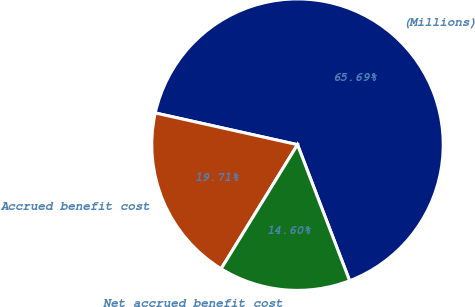<chart> <loc_0><loc_0><loc_500><loc_500><pie_chart><fcel>(Millions)<fcel>Accrued benefit cost<fcel>Net accrued benefit cost<nl><fcel>65.69%<fcel>19.71%<fcel>14.6%<nl></chart> 